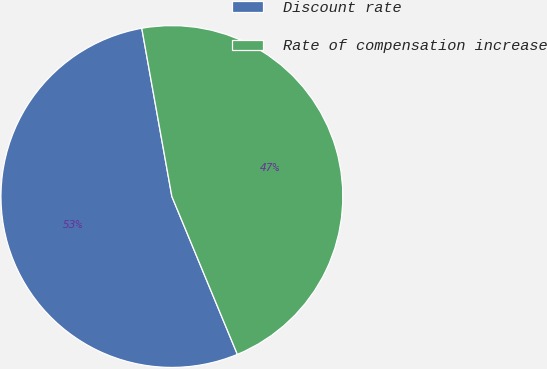Convert chart. <chart><loc_0><loc_0><loc_500><loc_500><pie_chart><fcel>Discount rate<fcel>Rate of compensation increase<nl><fcel>53.44%<fcel>46.56%<nl></chart> 